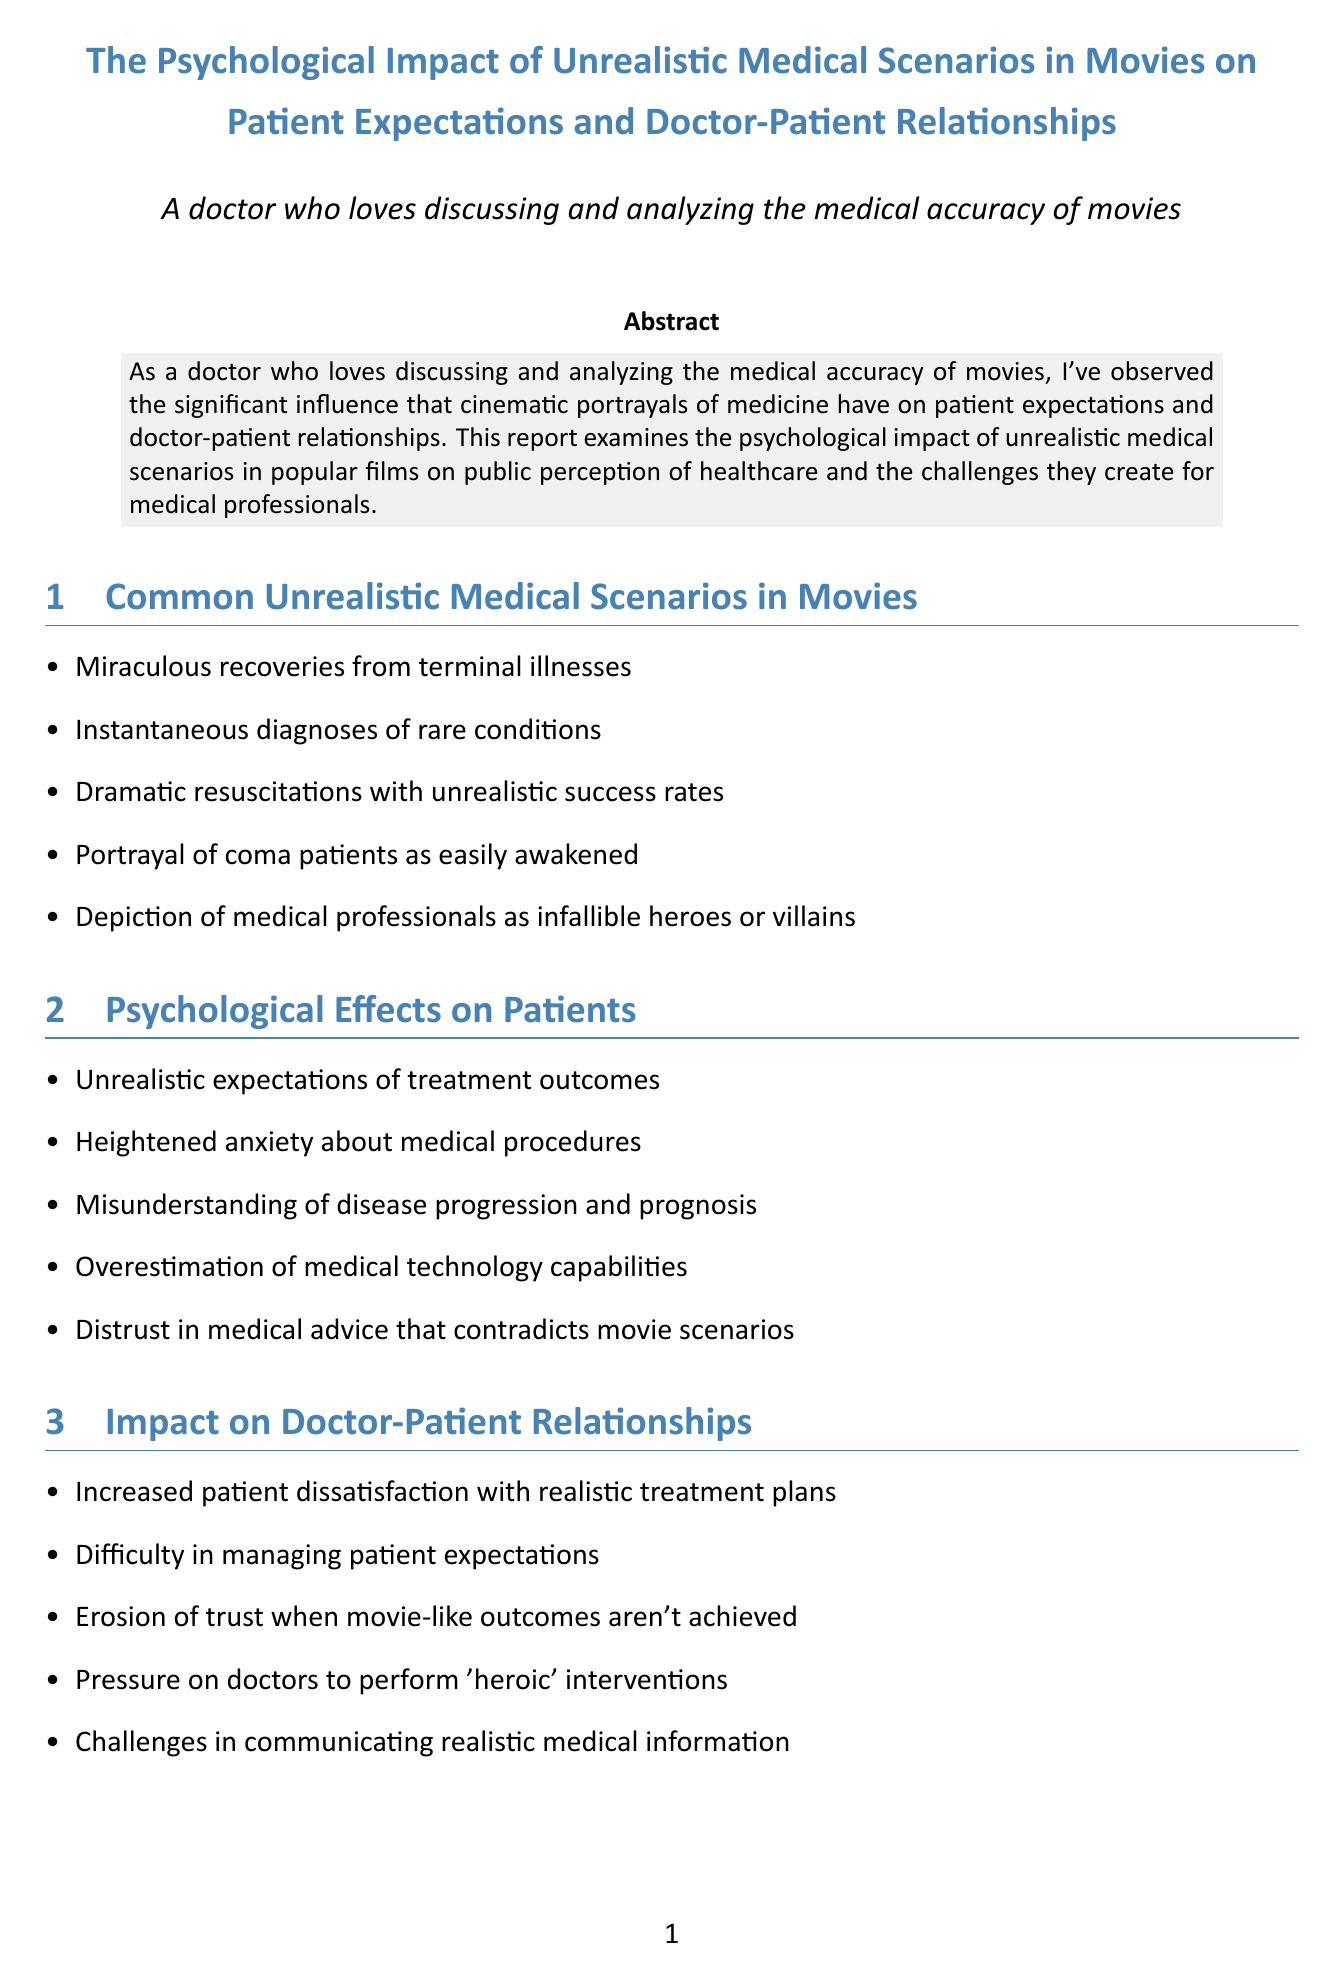What are some common unrealistic medical scenarios in movies? The document lists several scenarios, including miraculous recoveries and dramatic resuscitations.
Answer: Miraculous recoveries from terminal illnesses, Instantaneous diagnoses of rare conditions, Dramatic resuscitations with unrealistic success rates, Portrayal of coma patients as easily awakened, Depiction of medical professionals as infallible heroes or villains What is a psychological effect on patients caused by unrealistic medical portrayals? The report outlines multiple psychological effects, one being heightened anxiety about medical procedures.
Answer: Heightened anxiety about medical procedures Which movie is cited for inflated expectations of surgical success rates? The document lists case studies, including Grey's Anatomy for this specific expectation.
Answer: Grey's Anatomy Who is one expert mentioned in the report? The document provides names of experts, including Dr. Atul Gawande, who shares an opinion on cinematic portrayals.
Answer: Dr. Atul Gawande What is recommended to address the impact of unrealistic medical scenarios? The document lists strategies, one of which is educating patients about movie medicine versus reality.
Answer: Educating patients about the differences between movie medicine and reality What year was the article "The Influence of Movie Portrayals of Cancer on Public Understanding of Cancer Care" published? The document provides a publication year for this reference.
Answer: 2019 How has entertainment influenced patient expectations? The report elaborates on the role of movies in shaping public perception of healthcare and creating unrealistic expectations.
Answer: Movies significantly impact patient expectations and doctor-patient relationships What is a consequence of unrealistic portrayals on doctor-patient relationships? The document explains how movie-like outcomes may erode trust between patients and doctors.
Answer: Erosion of trust when movie-like outcomes aren't achieved 